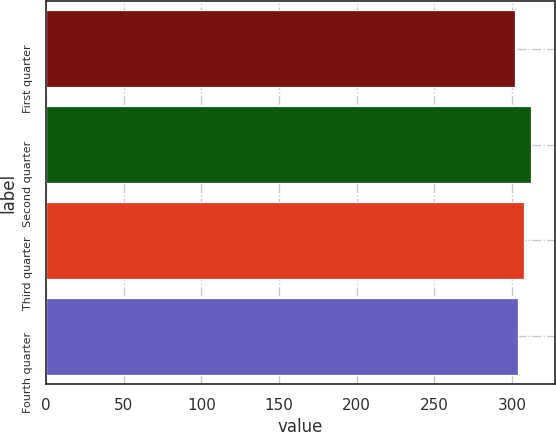Convert chart to OTSL. <chart><loc_0><loc_0><loc_500><loc_500><bar_chart><fcel>First quarter<fcel>Second quarter<fcel>Third quarter<fcel>Fourth quarter<nl><fcel>301.74<fcel>312<fcel>307.78<fcel>303.75<nl></chart> 